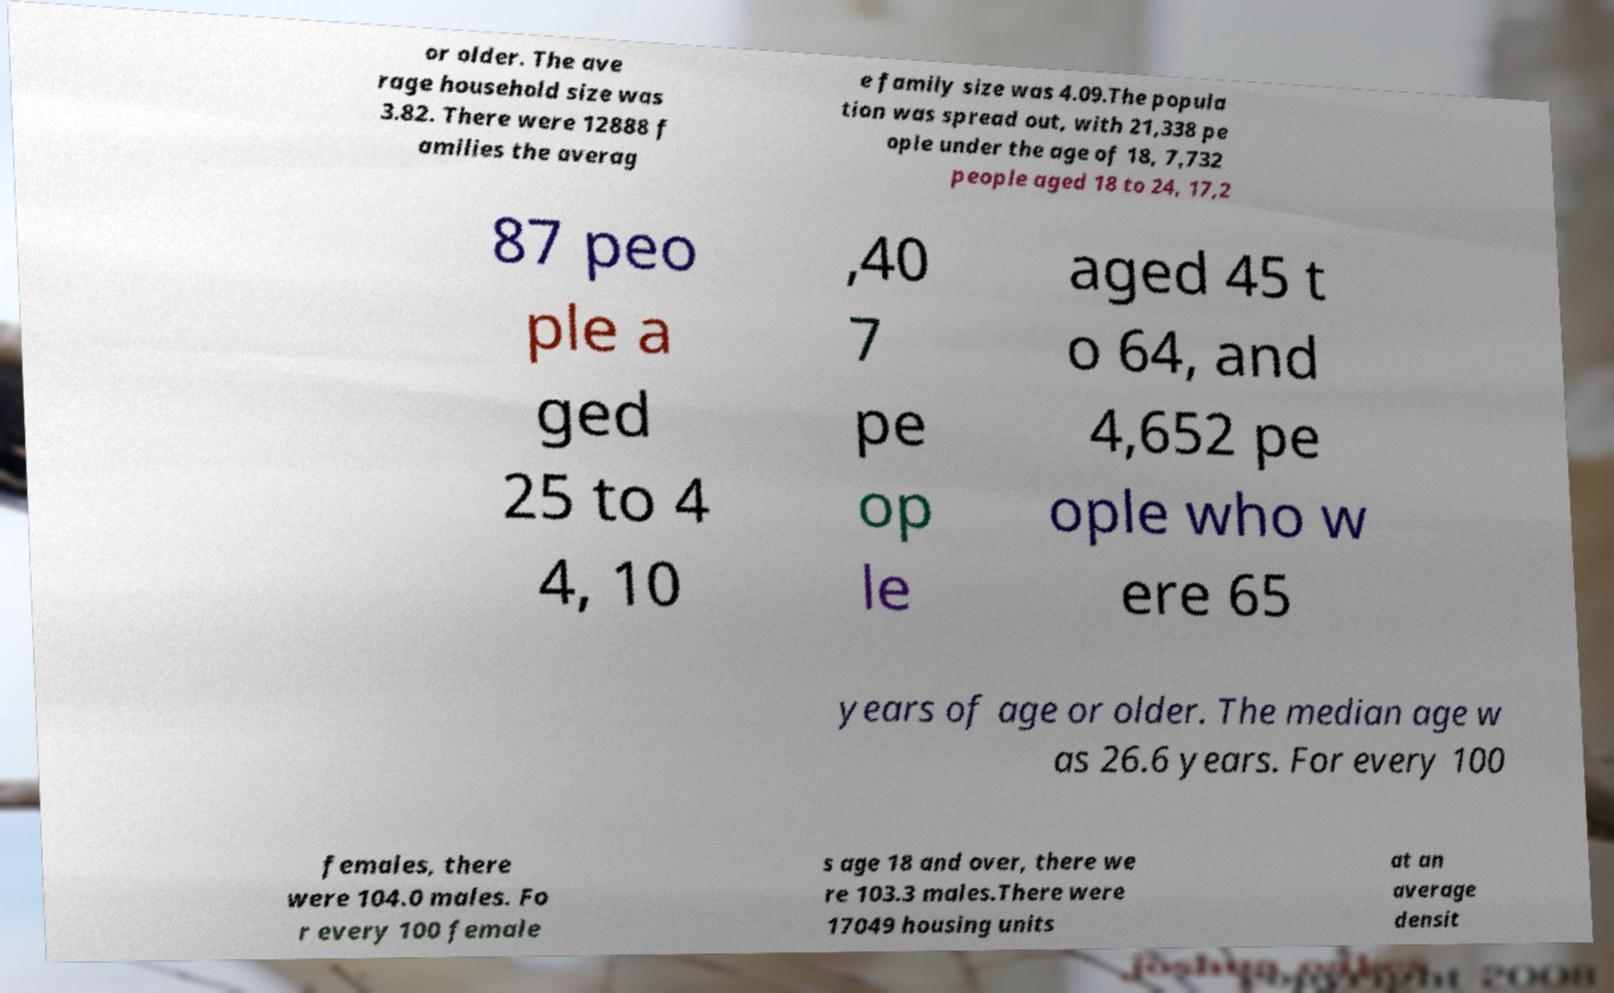Could you assist in decoding the text presented in this image and type it out clearly? or older. The ave rage household size was 3.82. There were 12888 f amilies the averag e family size was 4.09.The popula tion was spread out, with 21,338 pe ople under the age of 18, 7,732 people aged 18 to 24, 17,2 87 peo ple a ged 25 to 4 4, 10 ,40 7 pe op le aged 45 t o 64, and 4,652 pe ople who w ere 65 years of age or older. The median age w as 26.6 years. For every 100 females, there were 104.0 males. Fo r every 100 female s age 18 and over, there we re 103.3 males.There were 17049 housing units at an average densit 